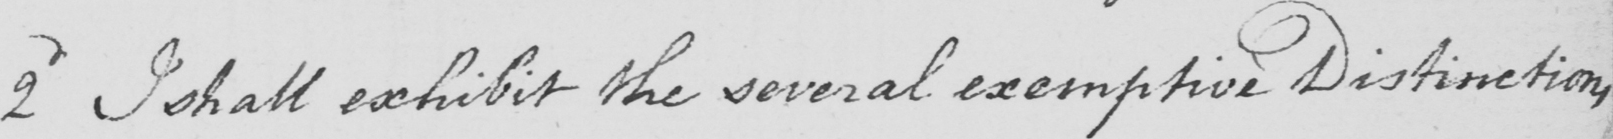Can you read and transcribe this handwriting? 2nd I shall exhibit the several exemptive Distinctions , 